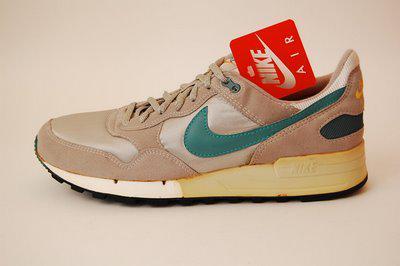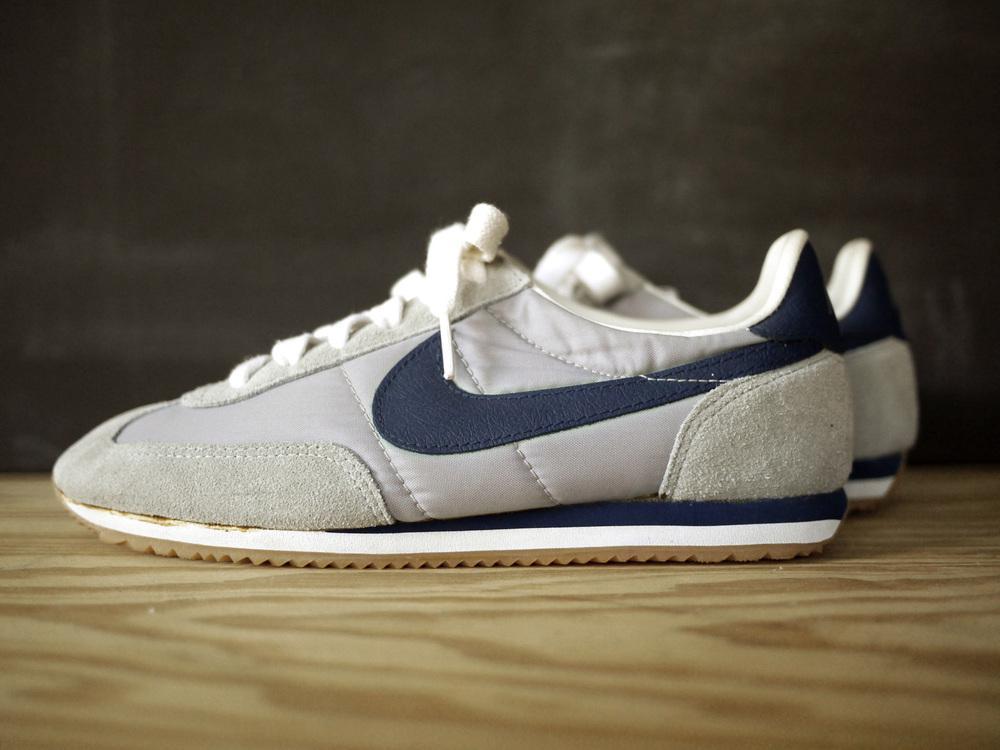The first image is the image on the left, the second image is the image on the right. Given the left and right images, does the statement "The left image contains no more than one shoe." hold true? Answer yes or no. Yes. The first image is the image on the left, the second image is the image on the right. Given the left and right images, does the statement "Every shoe is posed facing directly leftward, and one image contains a single shoe." hold true? Answer yes or no. Yes. 